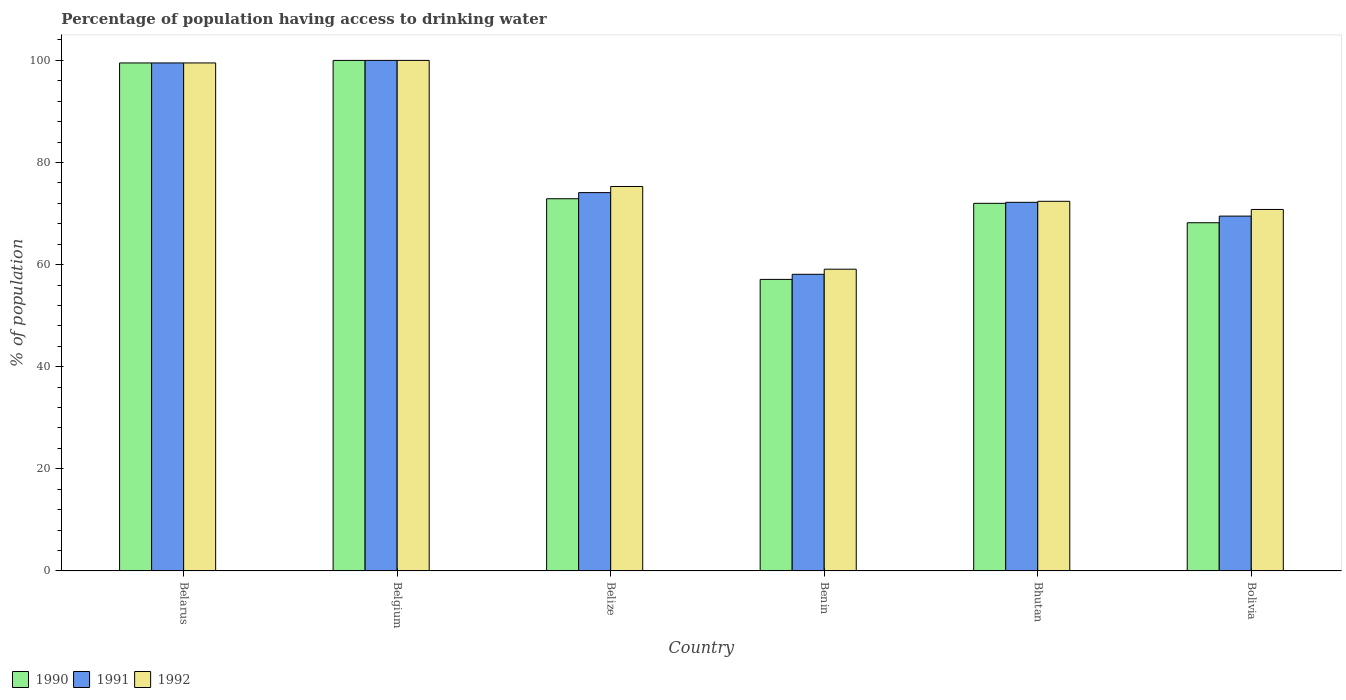How many different coloured bars are there?
Offer a terse response. 3. In how many cases, is the number of bars for a given country not equal to the number of legend labels?
Provide a succinct answer. 0. What is the percentage of population having access to drinking water in 1992 in Belgium?
Give a very brief answer. 100. Across all countries, what is the maximum percentage of population having access to drinking water in 1991?
Your response must be concise. 100. Across all countries, what is the minimum percentage of population having access to drinking water in 1992?
Provide a short and direct response. 59.1. In which country was the percentage of population having access to drinking water in 1990 maximum?
Provide a succinct answer. Belgium. In which country was the percentage of population having access to drinking water in 1992 minimum?
Keep it short and to the point. Benin. What is the total percentage of population having access to drinking water in 1992 in the graph?
Offer a very short reply. 477.1. What is the difference between the percentage of population having access to drinking water in 1990 in Belarus and that in Bolivia?
Provide a short and direct response. 31.3. What is the difference between the percentage of population having access to drinking water in 1991 in Belize and the percentage of population having access to drinking water in 1992 in Belarus?
Offer a very short reply. -25.4. What is the average percentage of population having access to drinking water in 1990 per country?
Your answer should be compact. 78.28. What is the difference between the percentage of population having access to drinking water of/in 1990 and percentage of population having access to drinking water of/in 1991 in Bolivia?
Give a very brief answer. -1.3. What is the ratio of the percentage of population having access to drinking water in 1992 in Belgium to that in Bolivia?
Keep it short and to the point. 1.41. Is the percentage of population having access to drinking water in 1990 in Belarus less than that in Bhutan?
Your answer should be compact. No. What is the difference between the highest and the second highest percentage of population having access to drinking water in 1990?
Your answer should be very brief. -26.6. What is the difference between the highest and the lowest percentage of population having access to drinking water in 1990?
Ensure brevity in your answer.  42.9. In how many countries, is the percentage of population having access to drinking water in 1990 greater than the average percentage of population having access to drinking water in 1990 taken over all countries?
Your answer should be very brief. 2. What does the 1st bar from the left in Belarus represents?
Keep it short and to the point. 1990. How many countries are there in the graph?
Keep it short and to the point. 6. What is the difference between two consecutive major ticks on the Y-axis?
Provide a short and direct response. 20. Does the graph contain any zero values?
Your answer should be compact. No. Does the graph contain grids?
Offer a very short reply. No. What is the title of the graph?
Provide a succinct answer. Percentage of population having access to drinking water. What is the label or title of the X-axis?
Your answer should be compact. Country. What is the label or title of the Y-axis?
Ensure brevity in your answer.  % of population. What is the % of population in 1990 in Belarus?
Offer a terse response. 99.5. What is the % of population of 1991 in Belarus?
Your answer should be compact. 99.5. What is the % of population of 1992 in Belarus?
Your answer should be very brief. 99.5. What is the % of population in 1991 in Belgium?
Ensure brevity in your answer.  100. What is the % of population of 1992 in Belgium?
Provide a short and direct response. 100. What is the % of population in 1990 in Belize?
Provide a succinct answer. 72.9. What is the % of population in 1991 in Belize?
Ensure brevity in your answer.  74.1. What is the % of population of 1992 in Belize?
Provide a short and direct response. 75.3. What is the % of population of 1990 in Benin?
Provide a short and direct response. 57.1. What is the % of population of 1991 in Benin?
Ensure brevity in your answer.  58.1. What is the % of population in 1992 in Benin?
Keep it short and to the point. 59.1. What is the % of population of 1991 in Bhutan?
Ensure brevity in your answer.  72.2. What is the % of population of 1992 in Bhutan?
Provide a succinct answer. 72.4. What is the % of population in 1990 in Bolivia?
Provide a short and direct response. 68.2. What is the % of population of 1991 in Bolivia?
Your answer should be compact. 69.5. What is the % of population of 1992 in Bolivia?
Make the answer very short. 70.8. Across all countries, what is the maximum % of population of 1990?
Ensure brevity in your answer.  100. Across all countries, what is the minimum % of population of 1990?
Your answer should be compact. 57.1. Across all countries, what is the minimum % of population in 1991?
Your response must be concise. 58.1. Across all countries, what is the minimum % of population of 1992?
Provide a short and direct response. 59.1. What is the total % of population of 1990 in the graph?
Offer a terse response. 469.7. What is the total % of population in 1991 in the graph?
Keep it short and to the point. 473.4. What is the total % of population in 1992 in the graph?
Your answer should be very brief. 477.1. What is the difference between the % of population in 1990 in Belarus and that in Belgium?
Offer a very short reply. -0.5. What is the difference between the % of population in 1990 in Belarus and that in Belize?
Ensure brevity in your answer.  26.6. What is the difference between the % of population in 1991 in Belarus and that in Belize?
Your answer should be very brief. 25.4. What is the difference between the % of population of 1992 in Belarus and that in Belize?
Your response must be concise. 24.2. What is the difference between the % of population in 1990 in Belarus and that in Benin?
Provide a succinct answer. 42.4. What is the difference between the % of population of 1991 in Belarus and that in Benin?
Your response must be concise. 41.4. What is the difference between the % of population of 1992 in Belarus and that in Benin?
Provide a short and direct response. 40.4. What is the difference between the % of population in 1991 in Belarus and that in Bhutan?
Your answer should be very brief. 27.3. What is the difference between the % of population in 1992 in Belarus and that in Bhutan?
Offer a terse response. 27.1. What is the difference between the % of population of 1990 in Belarus and that in Bolivia?
Give a very brief answer. 31.3. What is the difference between the % of population of 1991 in Belarus and that in Bolivia?
Provide a short and direct response. 30. What is the difference between the % of population in 1992 in Belarus and that in Bolivia?
Give a very brief answer. 28.7. What is the difference between the % of population in 1990 in Belgium and that in Belize?
Your response must be concise. 27.1. What is the difference between the % of population of 1991 in Belgium and that in Belize?
Your answer should be compact. 25.9. What is the difference between the % of population of 1992 in Belgium and that in Belize?
Provide a short and direct response. 24.7. What is the difference between the % of population in 1990 in Belgium and that in Benin?
Offer a very short reply. 42.9. What is the difference between the % of population of 1991 in Belgium and that in Benin?
Offer a very short reply. 41.9. What is the difference between the % of population of 1992 in Belgium and that in Benin?
Your answer should be compact. 40.9. What is the difference between the % of population in 1991 in Belgium and that in Bhutan?
Your answer should be very brief. 27.8. What is the difference between the % of population in 1992 in Belgium and that in Bhutan?
Provide a succinct answer. 27.6. What is the difference between the % of population of 1990 in Belgium and that in Bolivia?
Make the answer very short. 31.8. What is the difference between the % of population in 1991 in Belgium and that in Bolivia?
Ensure brevity in your answer.  30.5. What is the difference between the % of population in 1992 in Belgium and that in Bolivia?
Provide a succinct answer. 29.2. What is the difference between the % of population of 1991 in Belize and that in Bhutan?
Provide a short and direct response. 1.9. What is the difference between the % of population of 1992 in Belize and that in Bhutan?
Keep it short and to the point. 2.9. What is the difference between the % of population of 1991 in Belize and that in Bolivia?
Provide a succinct answer. 4.6. What is the difference between the % of population of 1992 in Belize and that in Bolivia?
Give a very brief answer. 4.5. What is the difference between the % of population of 1990 in Benin and that in Bhutan?
Provide a succinct answer. -14.9. What is the difference between the % of population in 1991 in Benin and that in Bhutan?
Give a very brief answer. -14.1. What is the difference between the % of population of 1992 in Benin and that in Bhutan?
Provide a succinct answer. -13.3. What is the difference between the % of population in 1990 in Benin and that in Bolivia?
Your response must be concise. -11.1. What is the difference between the % of population in 1992 in Benin and that in Bolivia?
Make the answer very short. -11.7. What is the difference between the % of population of 1990 in Bhutan and that in Bolivia?
Offer a very short reply. 3.8. What is the difference between the % of population in 1990 in Belarus and the % of population in 1992 in Belgium?
Offer a terse response. -0.5. What is the difference between the % of population in 1991 in Belarus and the % of population in 1992 in Belgium?
Ensure brevity in your answer.  -0.5. What is the difference between the % of population in 1990 in Belarus and the % of population in 1991 in Belize?
Make the answer very short. 25.4. What is the difference between the % of population of 1990 in Belarus and the % of population of 1992 in Belize?
Offer a terse response. 24.2. What is the difference between the % of population in 1991 in Belarus and the % of population in 1992 in Belize?
Offer a terse response. 24.2. What is the difference between the % of population of 1990 in Belarus and the % of population of 1991 in Benin?
Give a very brief answer. 41.4. What is the difference between the % of population of 1990 in Belarus and the % of population of 1992 in Benin?
Offer a very short reply. 40.4. What is the difference between the % of population of 1991 in Belarus and the % of population of 1992 in Benin?
Make the answer very short. 40.4. What is the difference between the % of population in 1990 in Belarus and the % of population in 1991 in Bhutan?
Make the answer very short. 27.3. What is the difference between the % of population of 1990 in Belarus and the % of population of 1992 in Bhutan?
Give a very brief answer. 27.1. What is the difference between the % of population in 1991 in Belarus and the % of population in 1992 in Bhutan?
Ensure brevity in your answer.  27.1. What is the difference between the % of population in 1990 in Belarus and the % of population in 1992 in Bolivia?
Your answer should be very brief. 28.7. What is the difference between the % of population of 1991 in Belarus and the % of population of 1992 in Bolivia?
Keep it short and to the point. 28.7. What is the difference between the % of population of 1990 in Belgium and the % of population of 1991 in Belize?
Your response must be concise. 25.9. What is the difference between the % of population of 1990 in Belgium and the % of population of 1992 in Belize?
Offer a very short reply. 24.7. What is the difference between the % of population of 1991 in Belgium and the % of population of 1992 in Belize?
Keep it short and to the point. 24.7. What is the difference between the % of population in 1990 in Belgium and the % of population in 1991 in Benin?
Your response must be concise. 41.9. What is the difference between the % of population in 1990 in Belgium and the % of population in 1992 in Benin?
Provide a short and direct response. 40.9. What is the difference between the % of population of 1991 in Belgium and the % of population of 1992 in Benin?
Give a very brief answer. 40.9. What is the difference between the % of population of 1990 in Belgium and the % of population of 1991 in Bhutan?
Provide a succinct answer. 27.8. What is the difference between the % of population in 1990 in Belgium and the % of population in 1992 in Bhutan?
Make the answer very short. 27.6. What is the difference between the % of population in 1991 in Belgium and the % of population in 1992 in Bhutan?
Provide a short and direct response. 27.6. What is the difference between the % of population of 1990 in Belgium and the % of population of 1991 in Bolivia?
Ensure brevity in your answer.  30.5. What is the difference between the % of population in 1990 in Belgium and the % of population in 1992 in Bolivia?
Offer a terse response. 29.2. What is the difference between the % of population in 1991 in Belgium and the % of population in 1992 in Bolivia?
Make the answer very short. 29.2. What is the difference between the % of population in 1990 in Belize and the % of population in 1991 in Benin?
Keep it short and to the point. 14.8. What is the difference between the % of population in 1991 in Belize and the % of population in 1992 in Benin?
Offer a very short reply. 15. What is the difference between the % of population of 1991 in Belize and the % of population of 1992 in Bhutan?
Your answer should be very brief. 1.7. What is the difference between the % of population in 1990 in Benin and the % of population in 1991 in Bhutan?
Make the answer very short. -15.1. What is the difference between the % of population in 1990 in Benin and the % of population in 1992 in Bhutan?
Keep it short and to the point. -15.3. What is the difference between the % of population of 1991 in Benin and the % of population of 1992 in Bhutan?
Provide a succinct answer. -14.3. What is the difference between the % of population in 1990 in Benin and the % of population in 1991 in Bolivia?
Your answer should be very brief. -12.4. What is the difference between the % of population of 1990 in Benin and the % of population of 1992 in Bolivia?
Your answer should be compact. -13.7. What is the difference between the % of population of 1991 in Benin and the % of population of 1992 in Bolivia?
Make the answer very short. -12.7. What is the average % of population of 1990 per country?
Your answer should be very brief. 78.28. What is the average % of population of 1991 per country?
Your response must be concise. 78.9. What is the average % of population of 1992 per country?
Keep it short and to the point. 79.52. What is the difference between the % of population of 1990 and % of population of 1991 in Belarus?
Your answer should be compact. 0. What is the difference between the % of population in 1990 and % of population in 1992 in Belarus?
Your response must be concise. 0. What is the difference between the % of population of 1990 and % of population of 1991 in Belgium?
Keep it short and to the point. 0. What is the difference between the % of population in 1990 and % of population in 1991 in Belize?
Your answer should be very brief. -1.2. What is the difference between the % of population of 1991 and % of population of 1992 in Belize?
Your answer should be compact. -1.2. What is the difference between the % of population of 1990 and % of population of 1991 in Benin?
Ensure brevity in your answer.  -1. What is the difference between the % of population of 1991 and % of population of 1992 in Benin?
Offer a very short reply. -1. What is the difference between the % of population in 1990 and % of population in 1991 in Bolivia?
Provide a short and direct response. -1.3. What is the difference between the % of population in 1990 and % of population in 1992 in Bolivia?
Offer a very short reply. -2.6. What is the difference between the % of population of 1991 and % of population of 1992 in Bolivia?
Offer a very short reply. -1.3. What is the ratio of the % of population of 1991 in Belarus to that in Belgium?
Provide a succinct answer. 0.99. What is the ratio of the % of population in 1992 in Belarus to that in Belgium?
Offer a very short reply. 0.99. What is the ratio of the % of population of 1990 in Belarus to that in Belize?
Your answer should be compact. 1.36. What is the ratio of the % of population in 1991 in Belarus to that in Belize?
Keep it short and to the point. 1.34. What is the ratio of the % of population of 1992 in Belarus to that in Belize?
Keep it short and to the point. 1.32. What is the ratio of the % of population of 1990 in Belarus to that in Benin?
Give a very brief answer. 1.74. What is the ratio of the % of population of 1991 in Belarus to that in Benin?
Your answer should be very brief. 1.71. What is the ratio of the % of population of 1992 in Belarus to that in Benin?
Provide a short and direct response. 1.68. What is the ratio of the % of population of 1990 in Belarus to that in Bhutan?
Offer a terse response. 1.38. What is the ratio of the % of population of 1991 in Belarus to that in Bhutan?
Provide a succinct answer. 1.38. What is the ratio of the % of population in 1992 in Belarus to that in Bhutan?
Provide a succinct answer. 1.37. What is the ratio of the % of population of 1990 in Belarus to that in Bolivia?
Give a very brief answer. 1.46. What is the ratio of the % of population of 1991 in Belarus to that in Bolivia?
Offer a very short reply. 1.43. What is the ratio of the % of population of 1992 in Belarus to that in Bolivia?
Your response must be concise. 1.41. What is the ratio of the % of population of 1990 in Belgium to that in Belize?
Give a very brief answer. 1.37. What is the ratio of the % of population of 1991 in Belgium to that in Belize?
Your response must be concise. 1.35. What is the ratio of the % of population of 1992 in Belgium to that in Belize?
Give a very brief answer. 1.33. What is the ratio of the % of population of 1990 in Belgium to that in Benin?
Give a very brief answer. 1.75. What is the ratio of the % of population of 1991 in Belgium to that in Benin?
Provide a short and direct response. 1.72. What is the ratio of the % of population in 1992 in Belgium to that in Benin?
Ensure brevity in your answer.  1.69. What is the ratio of the % of population of 1990 in Belgium to that in Bhutan?
Your answer should be very brief. 1.39. What is the ratio of the % of population of 1991 in Belgium to that in Bhutan?
Offer a terse response. 1.39. What is the ratio of the % of population of 1992 in Belgium to that in Bhutan?
Offer a terse response. 1.38. What is the ratio of the % of population of 1990 in Belgium to that in Bolivia?
Your response must be concise. 1.47. What is the ratio of the % of population of 1991 in Belgium to that in Bolivia?
Your answer should be very brief. 1.44. What is the ratio of the % of population of 1992 in Belgium to that in Bolivia?
Your answer should be very brief. 1.41. What is the ratio of the % of population in 1990 in Belize to that in Benin?
Provide a short and direct response. 1.28. What is the ratio of the % of population of 1991 in Belize to that in Benin?
Make the answer very short. 1.28. What is the ratio of the % of population in 1992 in Belize to that in Benin?
Ensure brevity in your answer.  1.27. What is the ratio of the % of population of 1990 in Belize to that in Bhutan?
Make the answer very short. 1.01. What is the ratio of the % of population of 1991 in Belize to that in Bhutan?
Your answer should be compact. 1.03. What is the ratio of the % of population in 1992 in Belize to that in Bhutan?
Your answer should be very brief. 1.04. What is the ratio of the % of population of 1990 in Belize to that in Bolivia?
Your answer should be compact. 1.07. What is the ratio of the % of population of 1991 in Belize to that in Bolivia?
Provide a succinct answer. 1.07. What is the ratio of the % of population of 1992 in Belize to that in Bolivia?
Provide a short and direct response. 1.06. What is the ratio of the % of population in 1990 in Benin to that in Bhutan?
Offer a very short reply. 0.79. What is the ratio of the % of population in 1991 in Benin to that in Bhutan?
Offer a very short reply. 0.8. What is the ratio of the % of population in 1992 in Benin to that in Bhutan?
Your answer should be very brief. 0.82. What is the ratio of the % of population of 1990 in Benin to that in Bolivia?
Your response must be concise. 0.84. What is the ratio of the % of population in 1991 in Benin to that in Bolivia?
Make the answer very short. 0.84. What is the ratio of the % of population in 1992 in Benin to that in Bolivia?
Keep it short and to the point. 0.83. What is the ratio of the % of population in 1990 in Bhutan to that in Bolivia?
Keep it short and to the point. 1.06. What is the ratio of the % of population in 1991 in Bhutan to that in Bolivia?
Provide a short and direct response. 1.04. What is the ratio of the % of population of 1992 in Bhutan to that in Bolivia?
Give a very brief answer. 1.02. What is the difference between the highest and the lowest % of population of 1990?
Offer a terse response. 42.9. What is the difference between the highest and the lowest % of population of 1991?
Your response must be concise. 41.9. What is the difference between the highest and the lowest % of population of 1992?
Offer a very short reply. 40.9. 